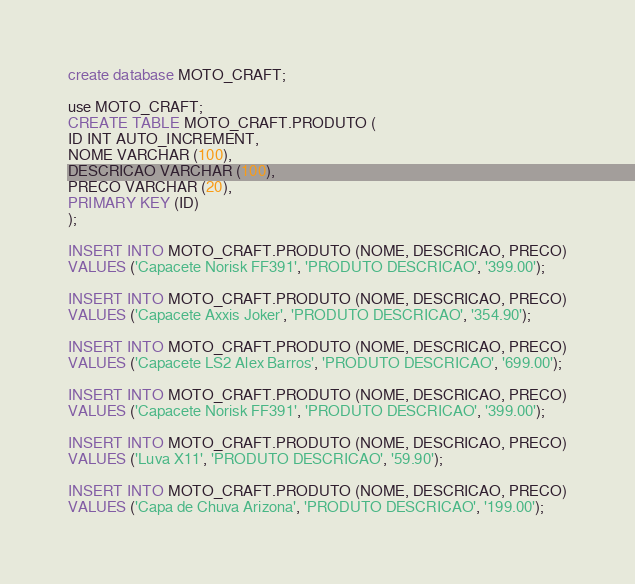Convert code to text. <code><loc_0><loc_0><loc_500><loc_500><_SQL_>create database MOTO_CRAFT;

use MOTO_CRAFT;
CREATE TABLE MOTO_CRAFT.PRODUTO (
ID INT AUTO_INCREMENT,
NOME VARCHAR (100),
DESCRICAO VARCHAR (100),
PRECO VARCHAR (20),
PRIMARY KEY (ID)
);

INSERT INTO MOTO_CRAFT.PRODUTO (NOME, DESCRICAO, PRECO)
VALUES ('Capacete Norisk FF391', 'PRODUTO DESCRICAO', '399.00');

INSERT INTO MOTO_CRAFT.PRODUTO (NOME, DESCRICAO, PRECO)
VALUES ('Capacete Axxis Joker', 'PRODUTO DESCRICAO', '354.90');

INSERT INTO MOTO_CRAFT.PRODUTO (NOME, DESCRICAO, PRECO)
VALUES ('Capacete LS2 Alex Barros', 'PRODUTO DESCRICAO', '699.00');

INSERT INTO MOTO_CRAFT.PRODUTO (NOME, DESCRICAO, PRECO)
VALUES ('Capacete Norisk FF391', 'PRODUTO DESCRICAO', '399.00');

INSERT INTO MOTO_CRAFT.PRODUTO (NOME, DESCRICAO, PRECO)
VALUES ('Luva X11', 'PRODUTO DESCRICAO', '59.90');

INSERT INTO MOTO_CRAFT.PRODUTO (NOME, DESCRICAO, PRECO)
VALUES ('Capa de Chuva Arizona', 'PRODUTO DESCRICAO', '199.00');

</code> 